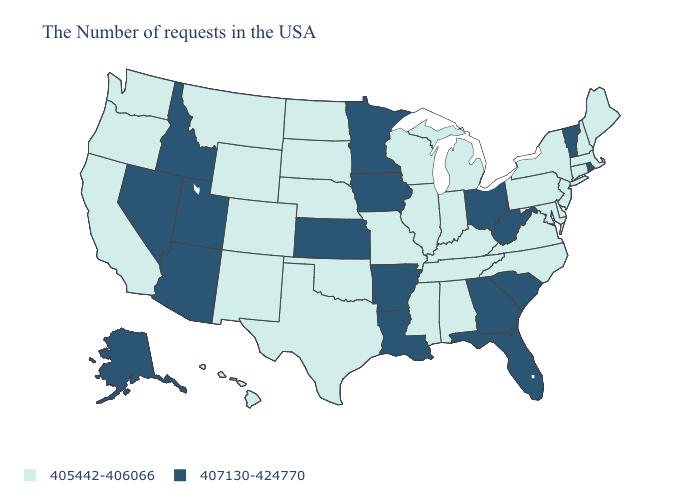Does Colorado have the highest value in the West?
Give a very brief answer. No. Among the states that border Mississippi , does Tennessee have the highest value?
Quick response, please. No. What is the value of New Hampshire?
Be succinct. 405442-406066. Name the states that have a value in the range 405442-406066?
Answer briefly. Maine, Massachusetts, New Hampshire, Connecticut, New York, New Jersey, Delaware, Maryland, Pennsylvania, Virginia, North Carolina, Michigan, Kentucky, Indiana, Alabama, Tennessee, Wisconsin, Illinois, Mississippi, Missouri, Nebraska, Oklahoma, Texas, South Dakota, North Dakota, Wyoming, Colorado, New Mexico, Montana, California, Washington, Oregon, Hawaii. What is the value of Pennsylvania?
Give a very brief answer. 405442-406066. What is the lowest value in the USA?
Short answer required. 405442-406066. What is the lowest value in states that border South Dakota?
Answer briefly. 405442-406066. What is the highest value in states that border California?
Write a very short answer. 407130-424770. Name the states that have a value in the range 405442-406066?
Be succinct. Maine, Massachusetts, New Hampshire, Connecticut, New York, New Jersey, Delaware, Maryland, Pennsylvania, Virginia, North Carolina, Michigan, Kentucky, Indiana, Alabama, Tennessee, Wisconsin, Illinois, Mississippi, Missouri, Nebraska, Oklahoma, Texas, South Dakota, North Dakota, Wyoming, Colorado, New Mexico, Montana, California, Washington, Oregon, Hawaii. What is the highest value in the USA?
Concise answer only. 407130-424770. Among the states that border Idaho , does Montana have the highest value?
Be succinct. No. What is the value of South Dakota?
Answer briefly. 405442-406066. Name the states that have a value in the range 407130-424770?
Write a very short answer. Rhode Island, Vermont, South Carolina, West Virginia, Ohio, Florida, Georgia, Louisiana, Arkansas, Minnesota, Iowa, Kansas, Utah, Arizona, Idaho, Nevada, Alaska. Does Louisiana have the lowest value in the USA?
Write a very short answer. No. Among the states that border North Dakota , does Minnesota have the highest value?
Give a very brief answer. Yes. 